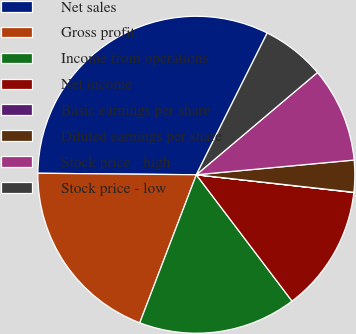Convert chart. <chart><loc_0><loc_0><loc_500><loc_500><pie_chart><fcel>Net sales<fcel>Gross profit<fcel>Income from operations<fcel>Net income<fcel>Basic earnings per share<fcel>Diluted earnings per share<fcel>Stock price - high<fcel>Stock price - low<nl><fcel>32.22%<fcel>19.34%<fcel>16.12%<fcel>12.9%<fcel>0.02%<fcel>3.24%<fcel>9.68%<fcel>6.46%<nl></chart> 